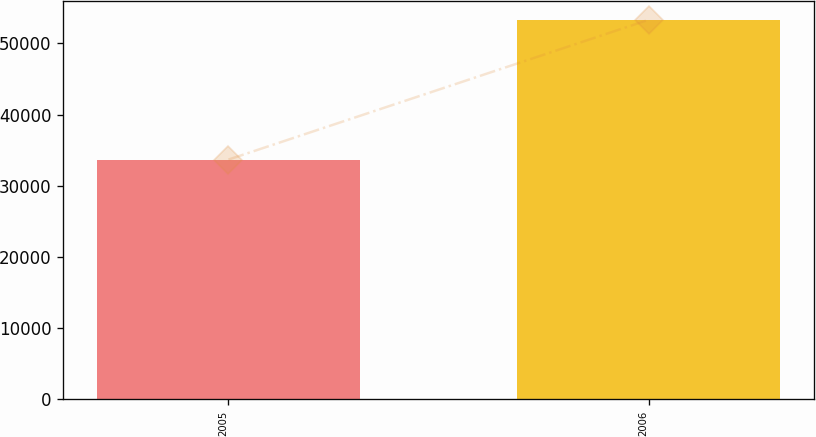Convert chart to OTSL. <chart><loc_0><loc_0><loc_500><loc_500><bar_chart><fcel>2005<fcel>2006<nl><fcel>33669<fcel>53308<nl></chart> 